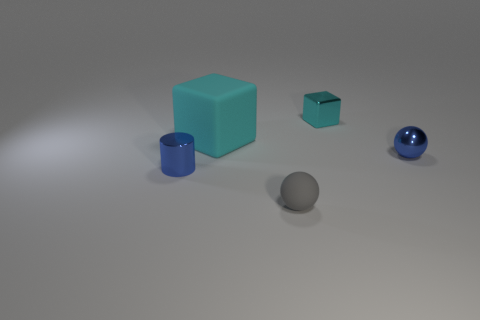There is a sphere that is the same color as the metal cylinder; what is its size?
Your answer should be very brief. Small. Does the cyan shiny block have the same size as the metallic cylinder?
Make the answer very short. Yes. There is a tiny sphere in front of the cylinder; what color is it?
Make the answer very short. Gray. Is there another small shiny sphere that has the same color as the tiny shiny ball?
Offer a very short reply. No. What color is the metallic block that is the same size as the rubber ball?
Ensure brevity in your answer.  Cyan. Does the big cyan thing have the same shape as the cyan shiny object?
Provide a succinct answer. Yes. There is a blue object on the right side of the big cyan matte cube; what material is it?
Your answer should be very brief. Metal. The rubber block has what color?
Provide a short and direct response. Cyan. Do the metal object behind the big block and the blue object that is left of the small gray rubber thing have the same size?
Make the answer very short. Yes. There is a metallic thing that is both in front of the cyan matte cube and to the right of the gray matte object; what is its size?
Make the answer very short. Small. 